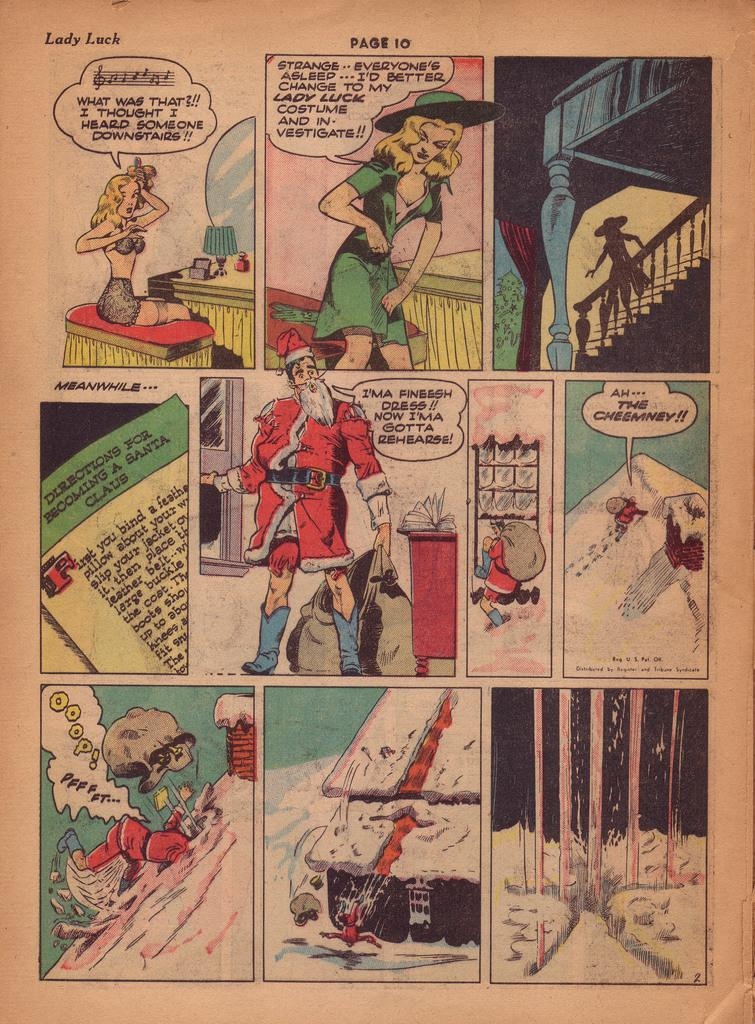<image>
Render a clear and concise summary of the photo. A Lady Luck comic book panel shows a woman getting dressed and a man dressed as Santa Claus. 